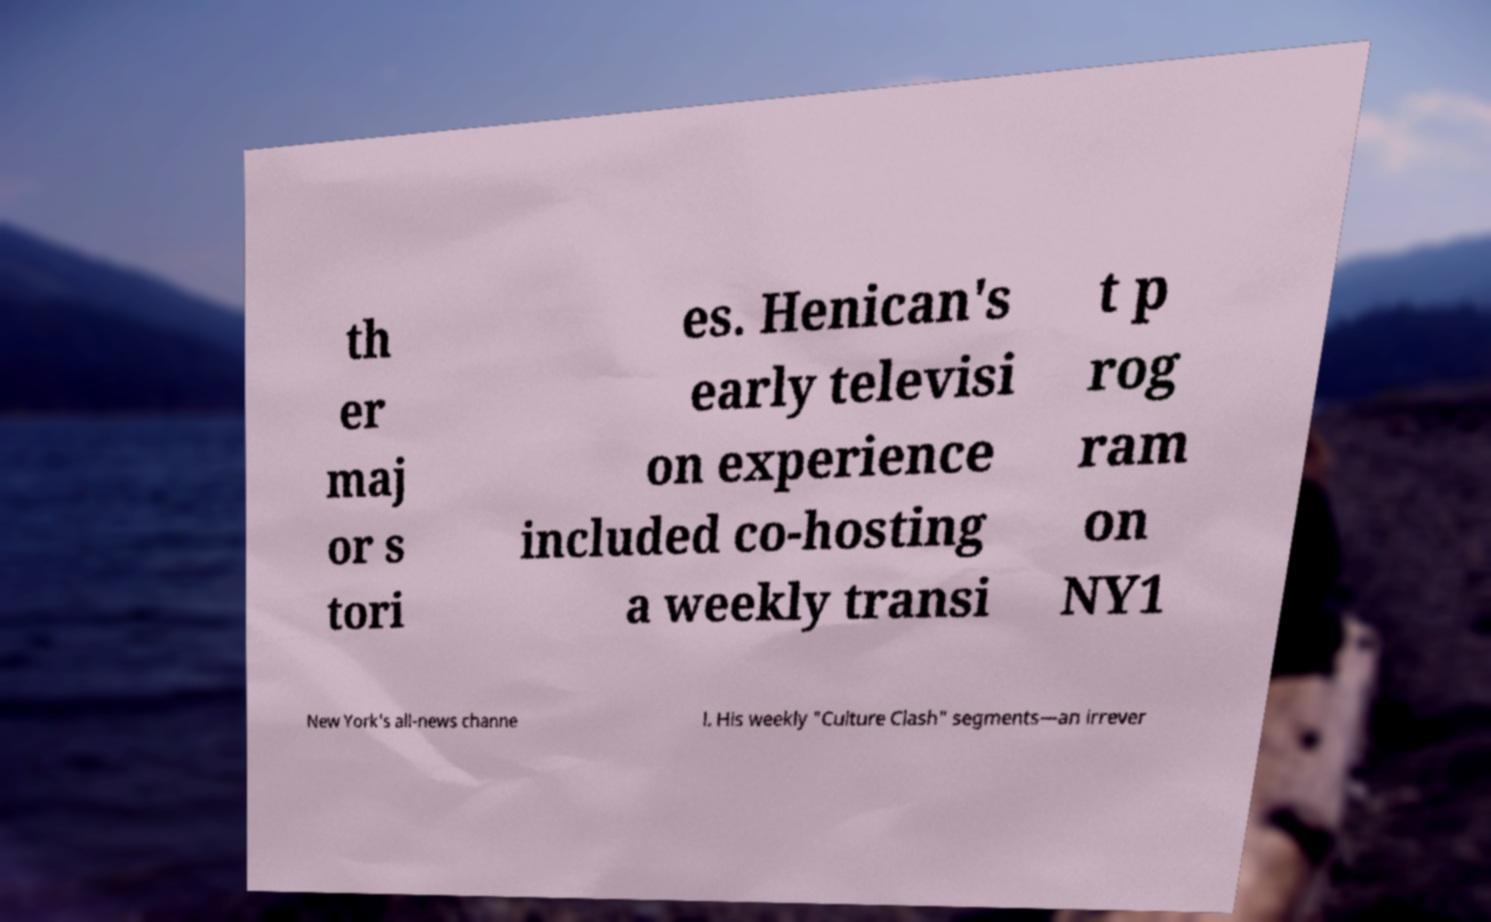Can you accurately transcribe the text from the provided image for me? th er maj or s tori es. Henican's early televisi on experience included co-hosting a weekly transi t p rog ram on NY1 New York's all-news channe l. His weekly "Culture Clash" segments—an irrever 